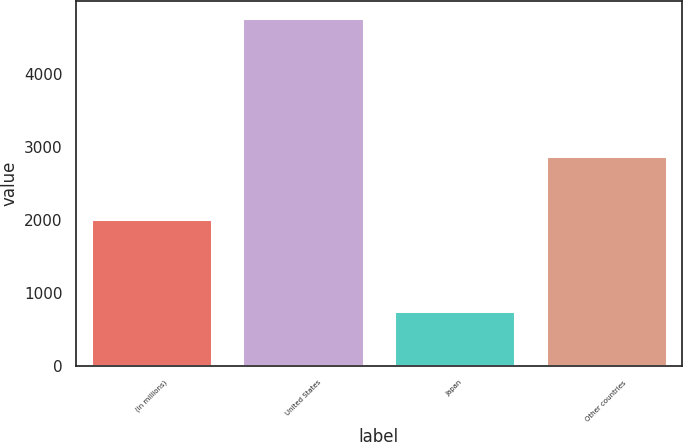Convert chart to OTSL. <chart><loc_0><loc_0><loc_500><loc_500><bar_chart><fcel>(in millions)<fcel>United States<fcel>Japan<fcel>Other countries<nl><fcel>2016<fcel>4759<fcel>750<fcel>2877<nl></chart> 